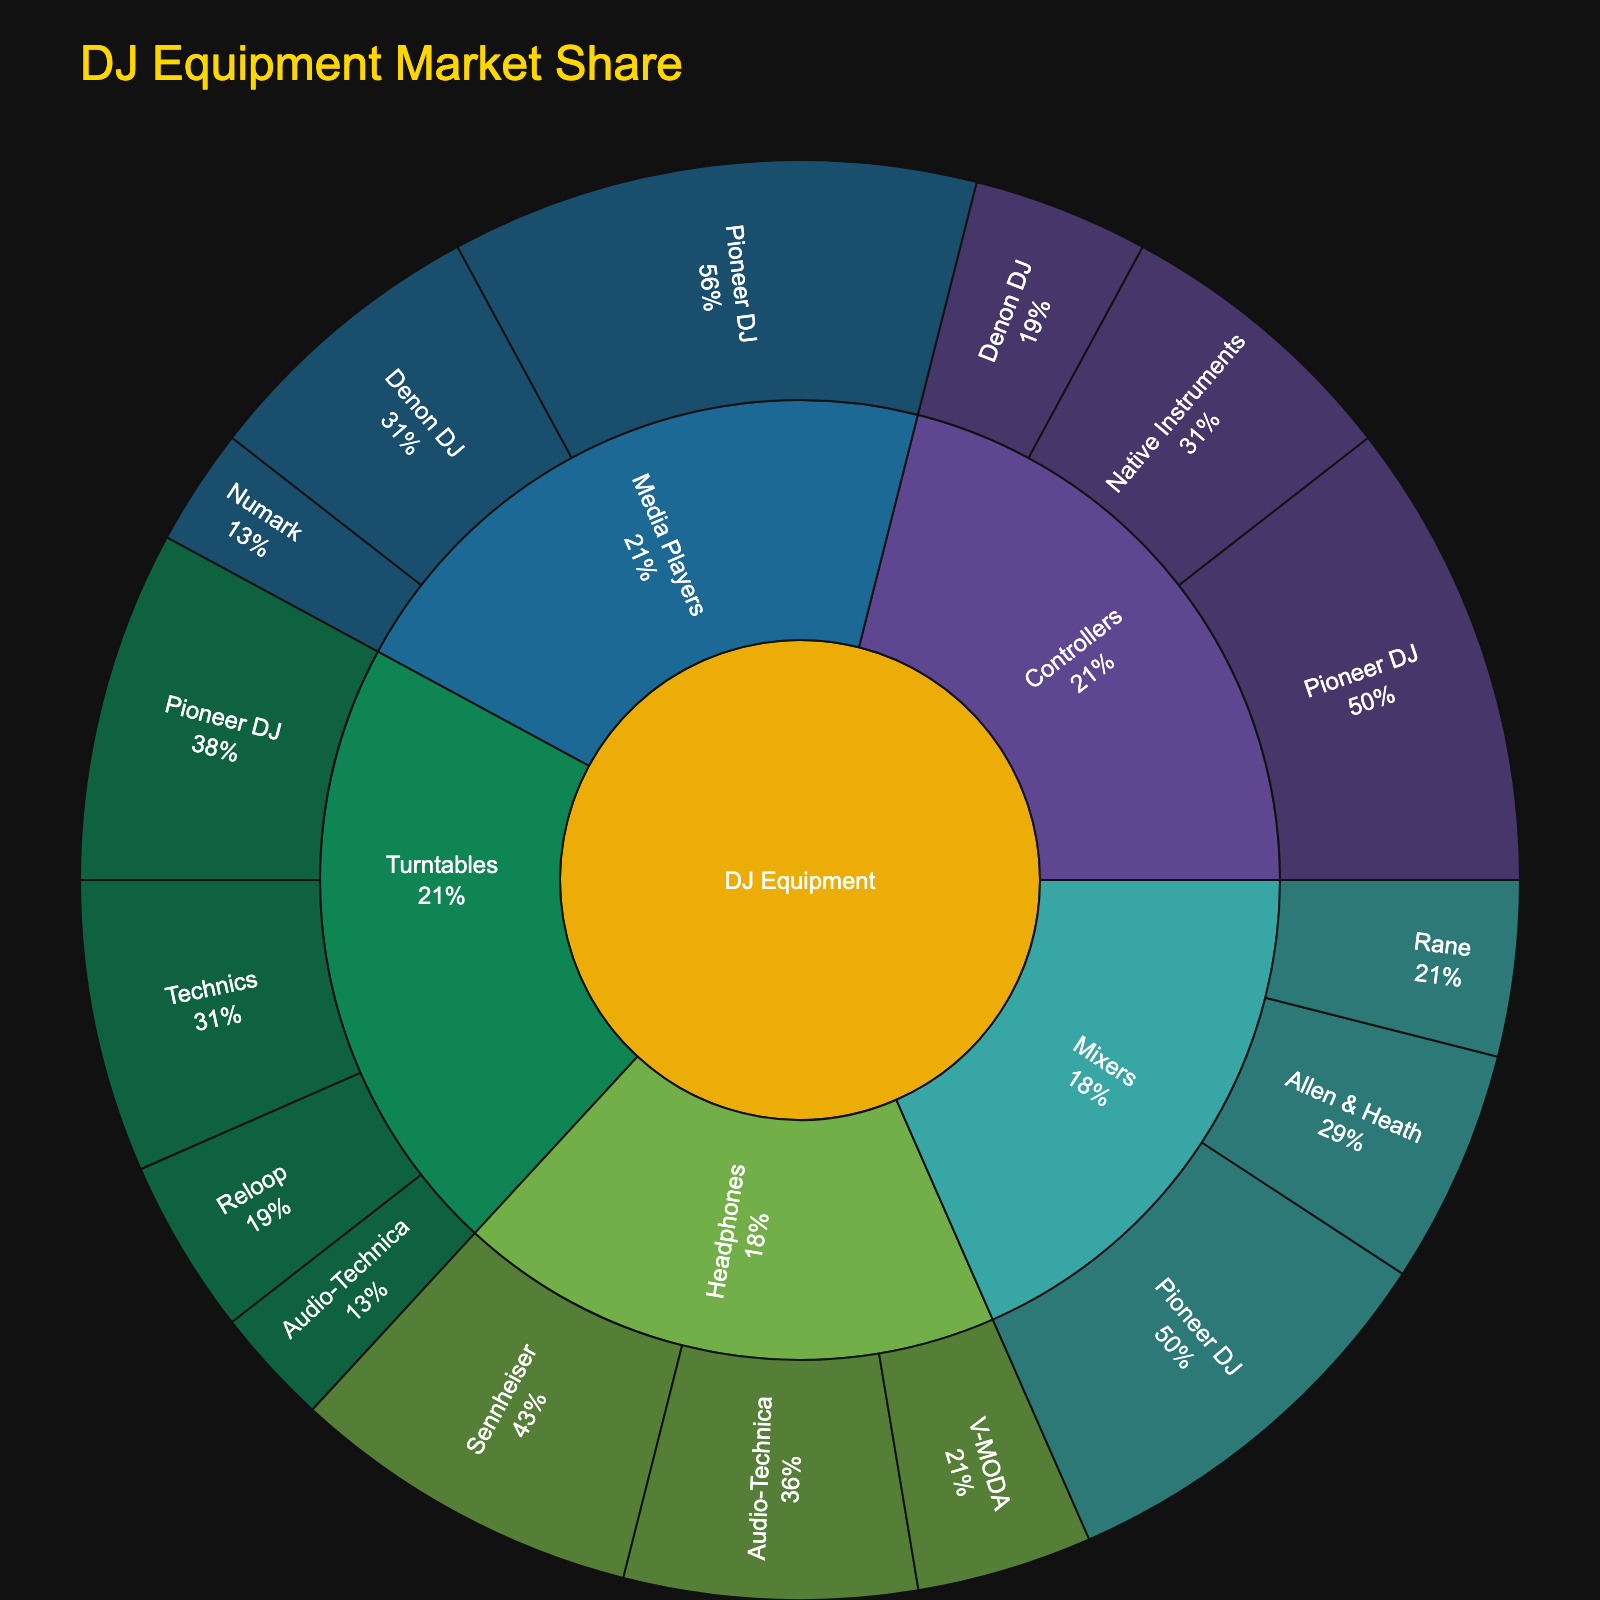what is the title of the plot? The title of a figure is usually displayed at the top and gives information about what the figure represents. In this case, the title is set in the code.
Answer: DJ Equipment Market Share Which category has the largest overall market share? By looking at the outermost level of the sunburst plot and comparing all categories, the category with the largest market share has the largest area.
Answer: Controllers Among the mixers, which brand has the highest market share? In the sunburst plot, identify the segment representing 'Mixers' and then visually compare the sizes of the sub-segments representing different brands within 'Mixers'.
Answer: Pioneer DJ What is the total market share percentage for Pioneer DJ across all subcategories? To find the total market share for a specific brand across all subcategories, sum up the market shares of 'Pioneer DJ' across different subcategories. In this plot: Turntables (30), Mixers (35), Controllers (40), Media Players (45). Total = 30 + 35 + 40 + 45 = 150. Then, calculate percentage of total market, assuming sum of all values is 360. (150 / 360) * 100
Answer: 41.67% Which subcategory has the smallest number of brands represented? Count the number of unique brands within each subcategory by looking at the inner ring of the sunburst plot.
Answer: Controllers How does the market share of Sennheiser headphones compare to V-MODA headphones? Find the segments for 'Sennheiser' and 'V-MODA' under the 'Headphones' category and compare their sizes directly. Sennheiser has a larger segment.
Answer: Sennheiser has a higher market share If you combine the market shares of Denon DJ's controllers and media players, what percentage of the total market share do they hold? Look for 'Denon DJ' in both 'Controllers' and 'Media Players'. Add their market shares: Controllers (15) + Media Players (25) = 40. Calculate the percentage of total market assuming total market is 360. (40/360)*100
Answer: 11.11% Which brand within turntables has the second highest market share? Locate the 'Turntables' category and visually compare the segments' sizes for each brand within that category. The second-largest segment after Pioneer DJ is 'Technics'.
Answer: Technics Between Audio-Technica turntables and Audio-Technica headphones, which one has a higher market share? Look for Audio-Technica within both 'Turntables' and 'Headphones'. Compare their sizes: Turntables (10) and Headphones (25).
Answer: Audio-Technica headphones 